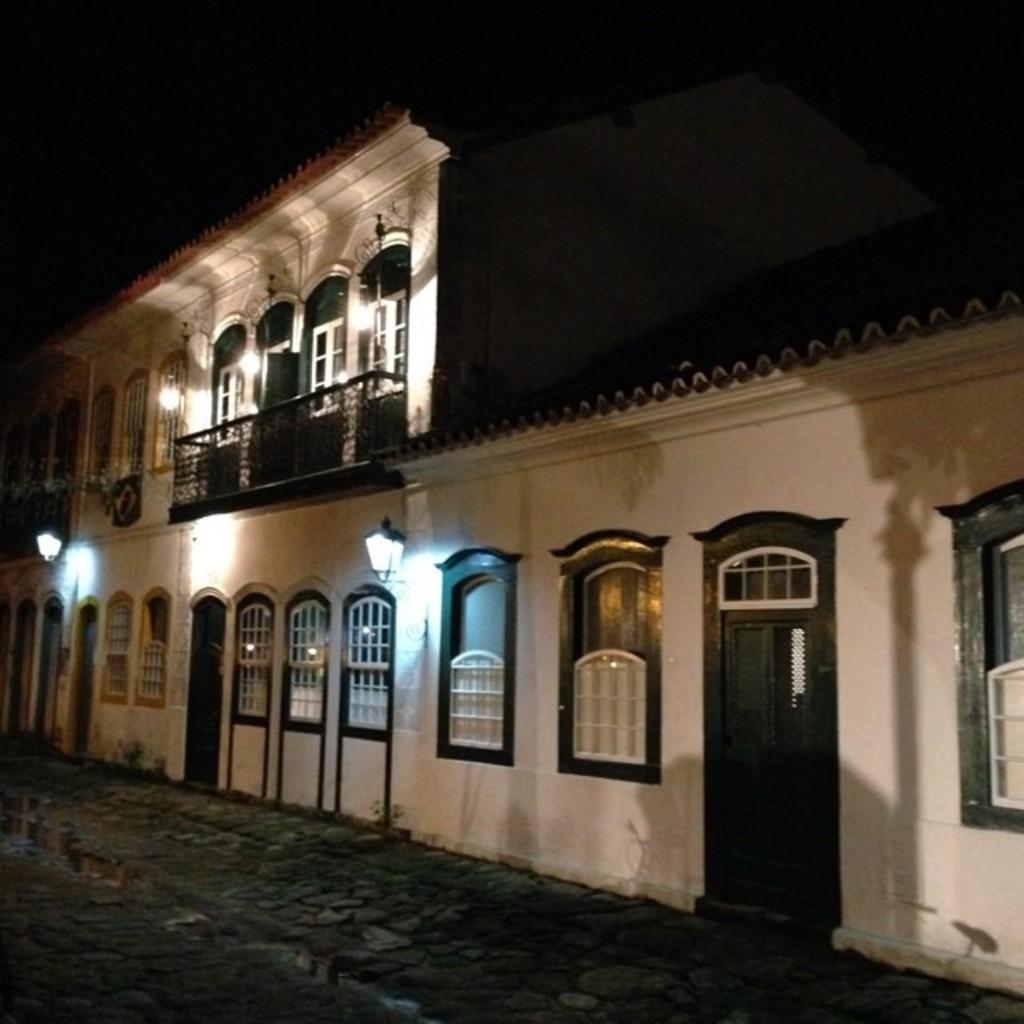What type of structure is present in the image? There is a building in the image. What can be seen illuminated in the image? There are lights visible in the image. What is located at the bottom of the image? There is a road at the bottom of the image. How many friends are holding a thread in the image? There are no friends or thread present in the image. What type of club can be seen in the image? There is no club present in the image. 